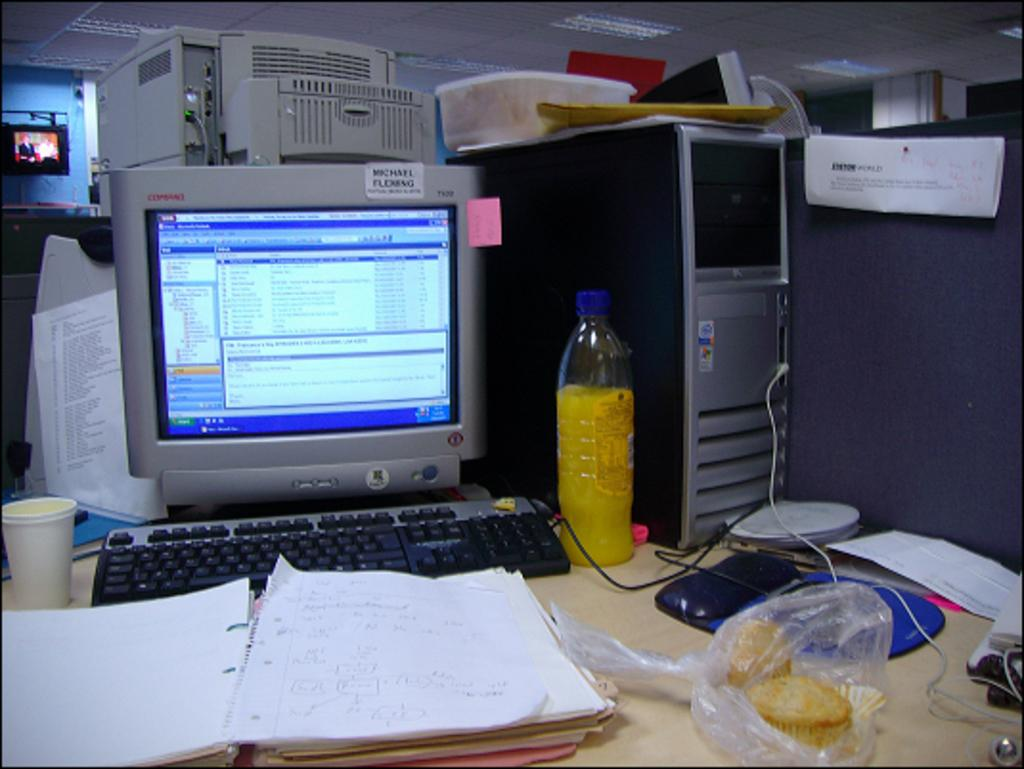What is the main subject of the image? There is a system in the image. What items can be seen on the table in the image? There are papers, a cup, food, and a bottle on the table in the image. Can you describe the background of the image? There is a screen in the background of the image. What hobbies does the beetle in the image enjoy? There is no beetle present in the image, so we cannot determine its hobbies. 